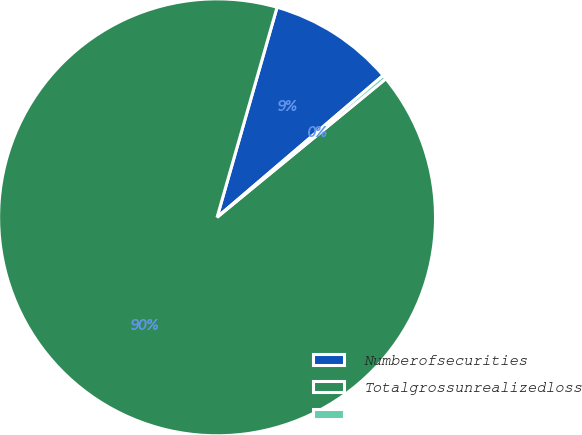Convert chart. <chart><loc_0><loc_0><loc_500><loc_500><pie_chart><fcel>Numberofsecurities<fcel>Totalgrossunrealizedloss<fcel>Unnamed: 2<nl><fcel>9.32%<fcel>90.37%<fcel>0.31%<nl></chart> 